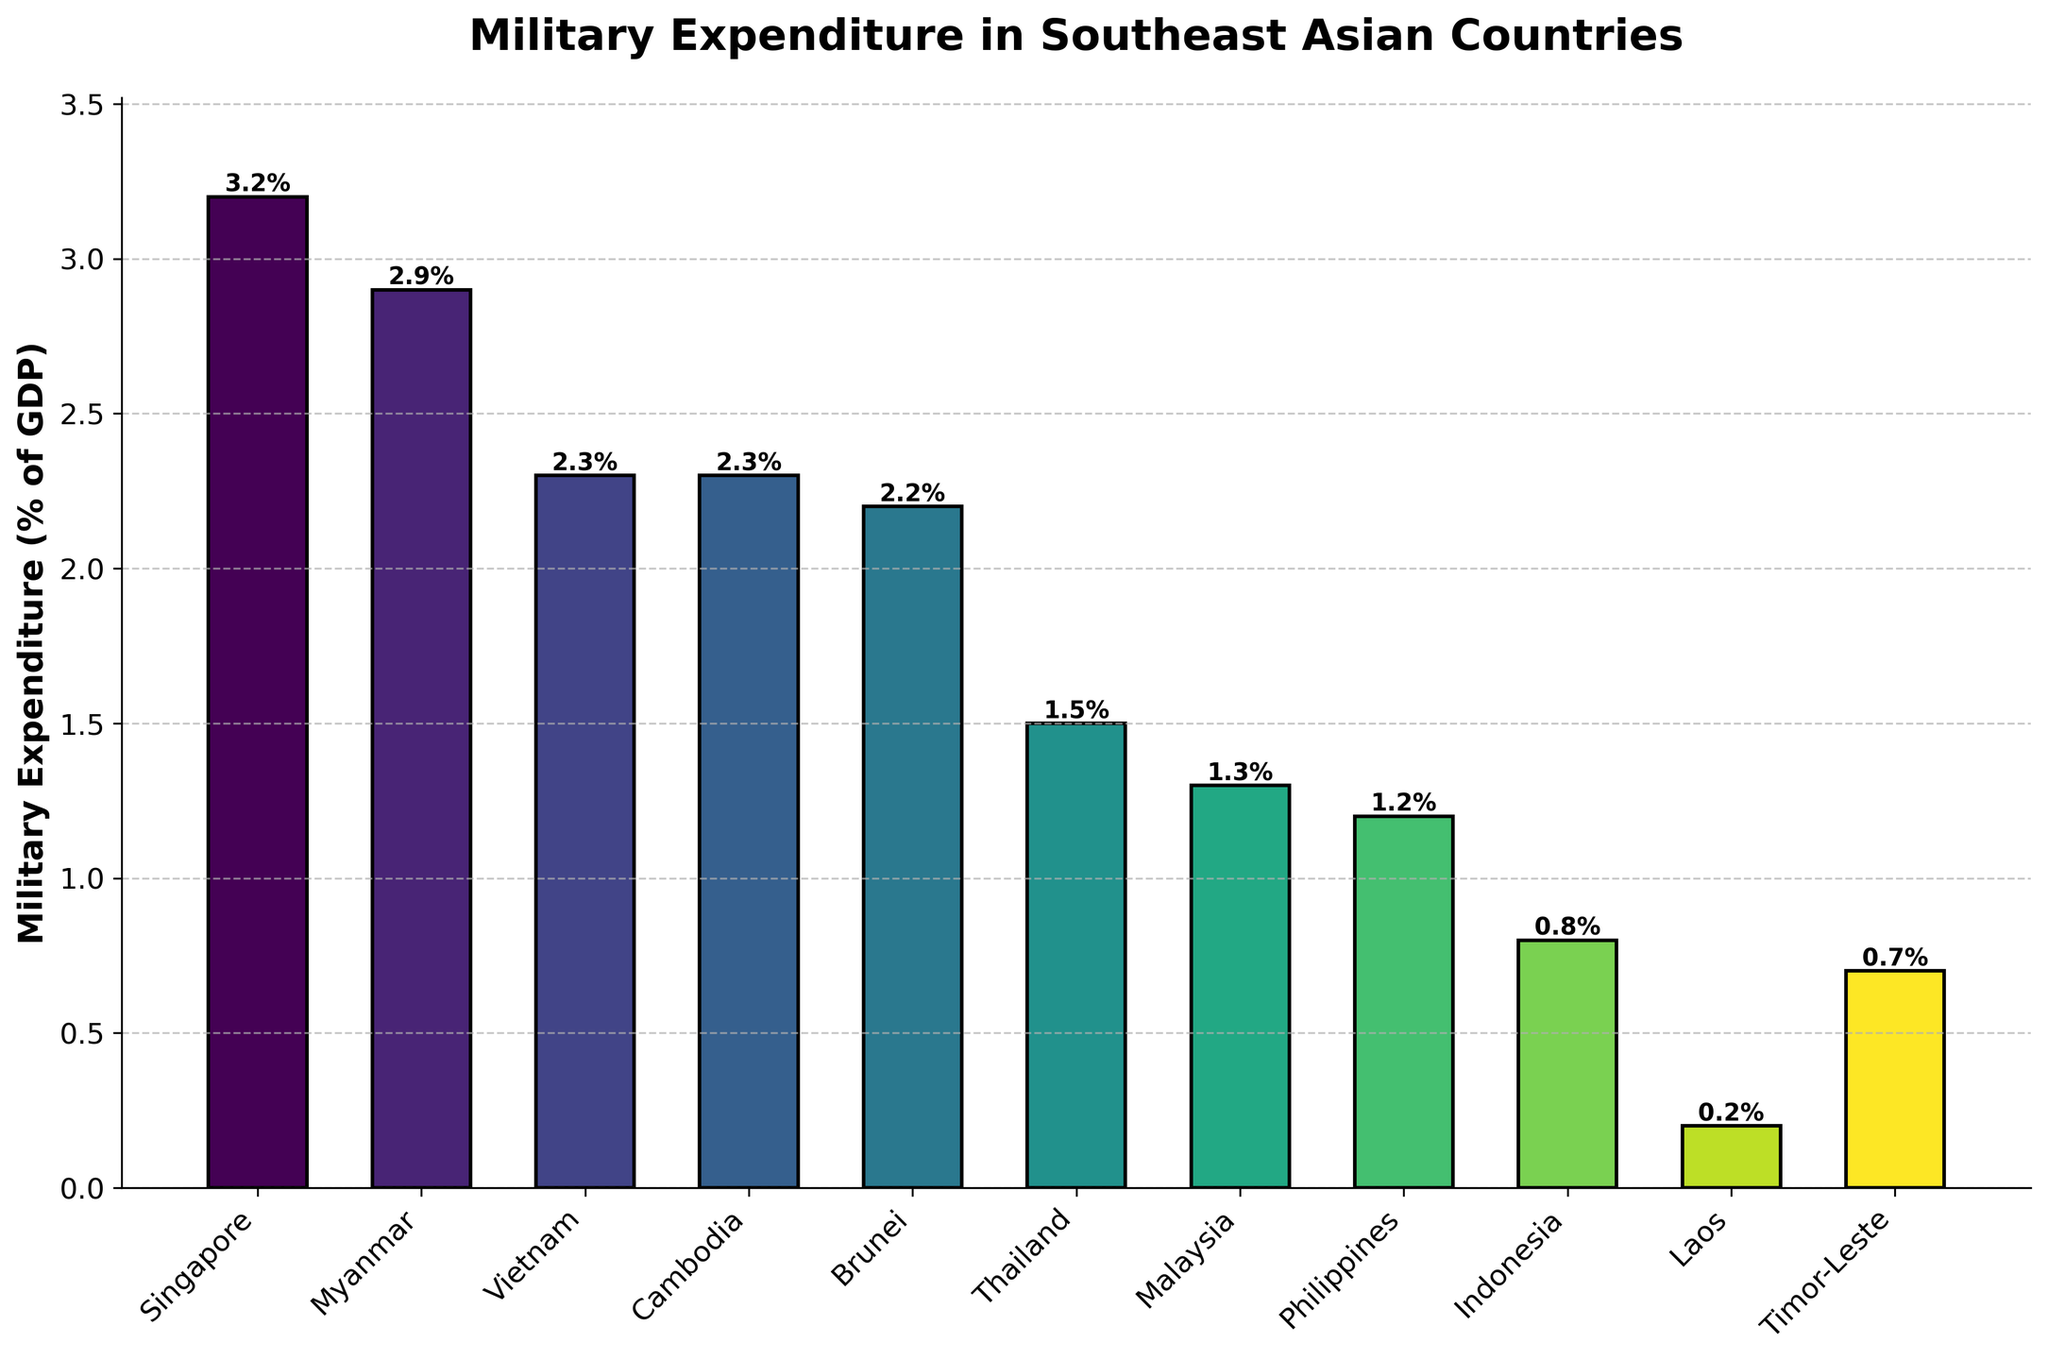Which country has the highest military expenditure as a percentage of GDP? By examining the heights of the bars, Singapore’s bar is the tallest among the countries, indicating the highest military expenditure as a percentage of GDP.
Answer: Singapore Which country has the lowest military expenditure as a percentage of GDP? By looking at the smallest bar in the chart, Laos has the shortest bar, indicating the lowest military expenditure as a percentage of GDP.
Answer: Laos How much higher is Singapore's military expenditure as a percentage of GDP compared to Malaysia's? Singapore's expenditure is 3.2% and Malaysia's is 1.3%. The difference is 3.2% - 1.3% = 1.9%.
Answer: 1.9% Which countries have the same military expenditure as a percentage of GDP? Both Vietnam and Cambodia have bars reaching up to 2.3%, indicating they have the same military expenditure as a percentage of GDP.
Answer: Vietnam and Cambodia Which countries have a military expenditure greater than 2% of GDP? By identifying the bars that extend above the 2% mark, the countries are Singapore, Myanmar, Vietnam, Cambodia, and Brunei.
Answer: Singapore, Myanmar, Vietnam, Cambodia, Brunei What is the average military expenditure as a percentage of GDP for all the countries combined? Sum the percentages and divide by the number of countries: (3.2 + 2.9 + 2.3 + 2.3 + 2.2 + 1.5 + 1.3 + 1.2 + 0.8 + 0.2 + 0.7) / 11 = 18.6 / 11 ≈ 1.69%
Answer: 1.69% How many countries have a military expenditure less than 1% of GDP? Count the bars that fall below the 1% mark: Indonesia, Laos, and Timor-Leste. There are three countries.
Answer: 3 If you combine the military expenditures of Thailand and Malaysia, what is the total percentage of GDP? Add the percentages: Thailand (1.5%) + Malaysia (1.3%) = 1.5 + 1.3 = 2.8%
Answer: 2.8% What is the median military expenditure as a percentage of GDP among these countries? Arrange the values in order and find the middle one: 0.2, 0.7, 0.8, 1.2, 1.3, 1.5, 2.2, 2.3, 2.3, 2.9, 3.2. The median value in this ordered list is 1.5%.
Answer: 1.5% Is Vietnam's military expenditure as a percentage of GDP greater than Thailand’s? Compare the bar heights of Vietnam (2.3%) and Thailand (1.5%). Yes, 2.3% is greater than 1.5%.
Answer: Yes 